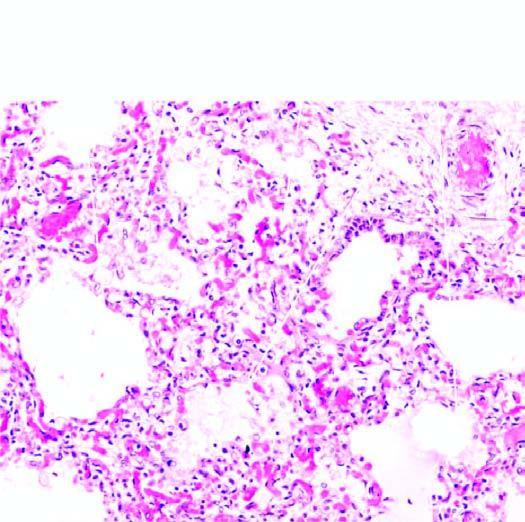s there congestion of septal walls while the air spaces contain pale oedema fluid and a few red cells?
Answer the question using a single word or phrase. Yes 